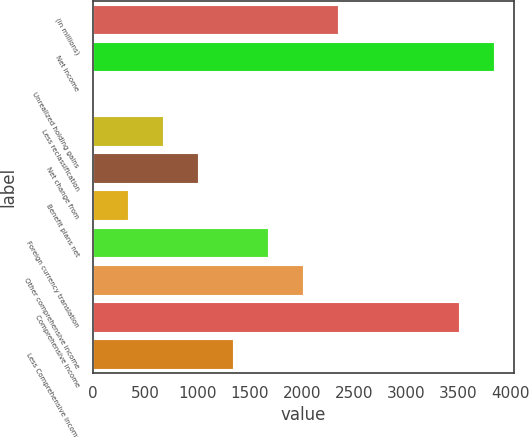Convert chart. <chart><loc_0><loc_0><loc_500><loc_500><bar_chart><fcel>(in millions)<fcel>Net income<fcel>Unrealized holding gains<fcel>Less reclassification<fcel>Net change from<fcel>Benefit plans net<fcel>Foreign currency translation<fcel>Other comprehensive income<fcel>Comprehensive income<fcel>Less Comprehensive income<nl><fcel>2346.7<fcel>3840.2<fcel>1<fcel>671.2<fcel>1006.3<fcel>336.1<fcel>1676.5<fcel>2011.6<fcel>3505.1<fcel>1341.4<nl></chart> 